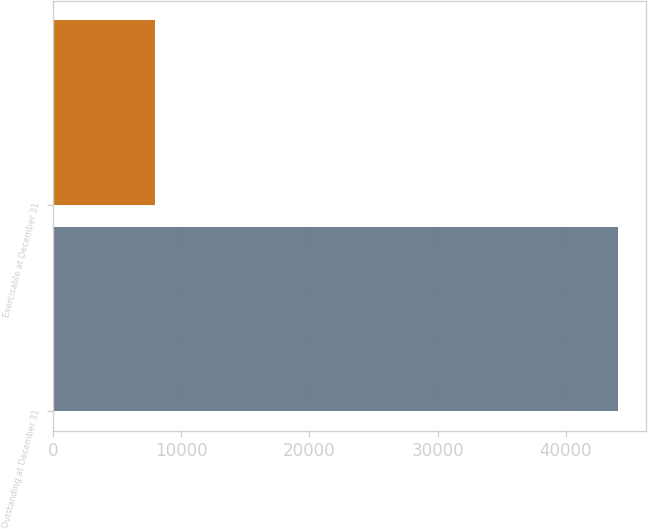Convert chart to OTSL. <chart><loc_0><loc_0><loc_500><loc_500><bar_chart><fcel>Outstanding at December 31<fcel>Exercisable at December 31<nl><fcel>44053<fcel>7920<nl></chart> 